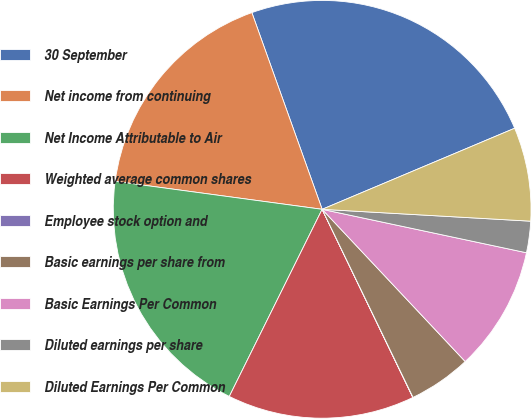Convert chart to OTSL. <chart><loc_0><loc_0><loc_500><loc_500><pie_chart><fcel>30 September<fcel>Net income from continuing<fcel>Net Income Attributable to Air<fcel>Weighted average common shares<fcel>Employee stock option and<fcel>Basic earnings per share from<fcel>Basic Earnings Per Common<fcel>Diluted earnings per share<fcel>Diluted Earnings Per Common<nl><fcel>24.12%<fcel>17.4%<fcel>19.81%<fcel>14.48%<fcel>0.02%<fcel>4.84%<fcel>9.66%<fcel>2.43%<fcel>7.25%<nl></chart> 